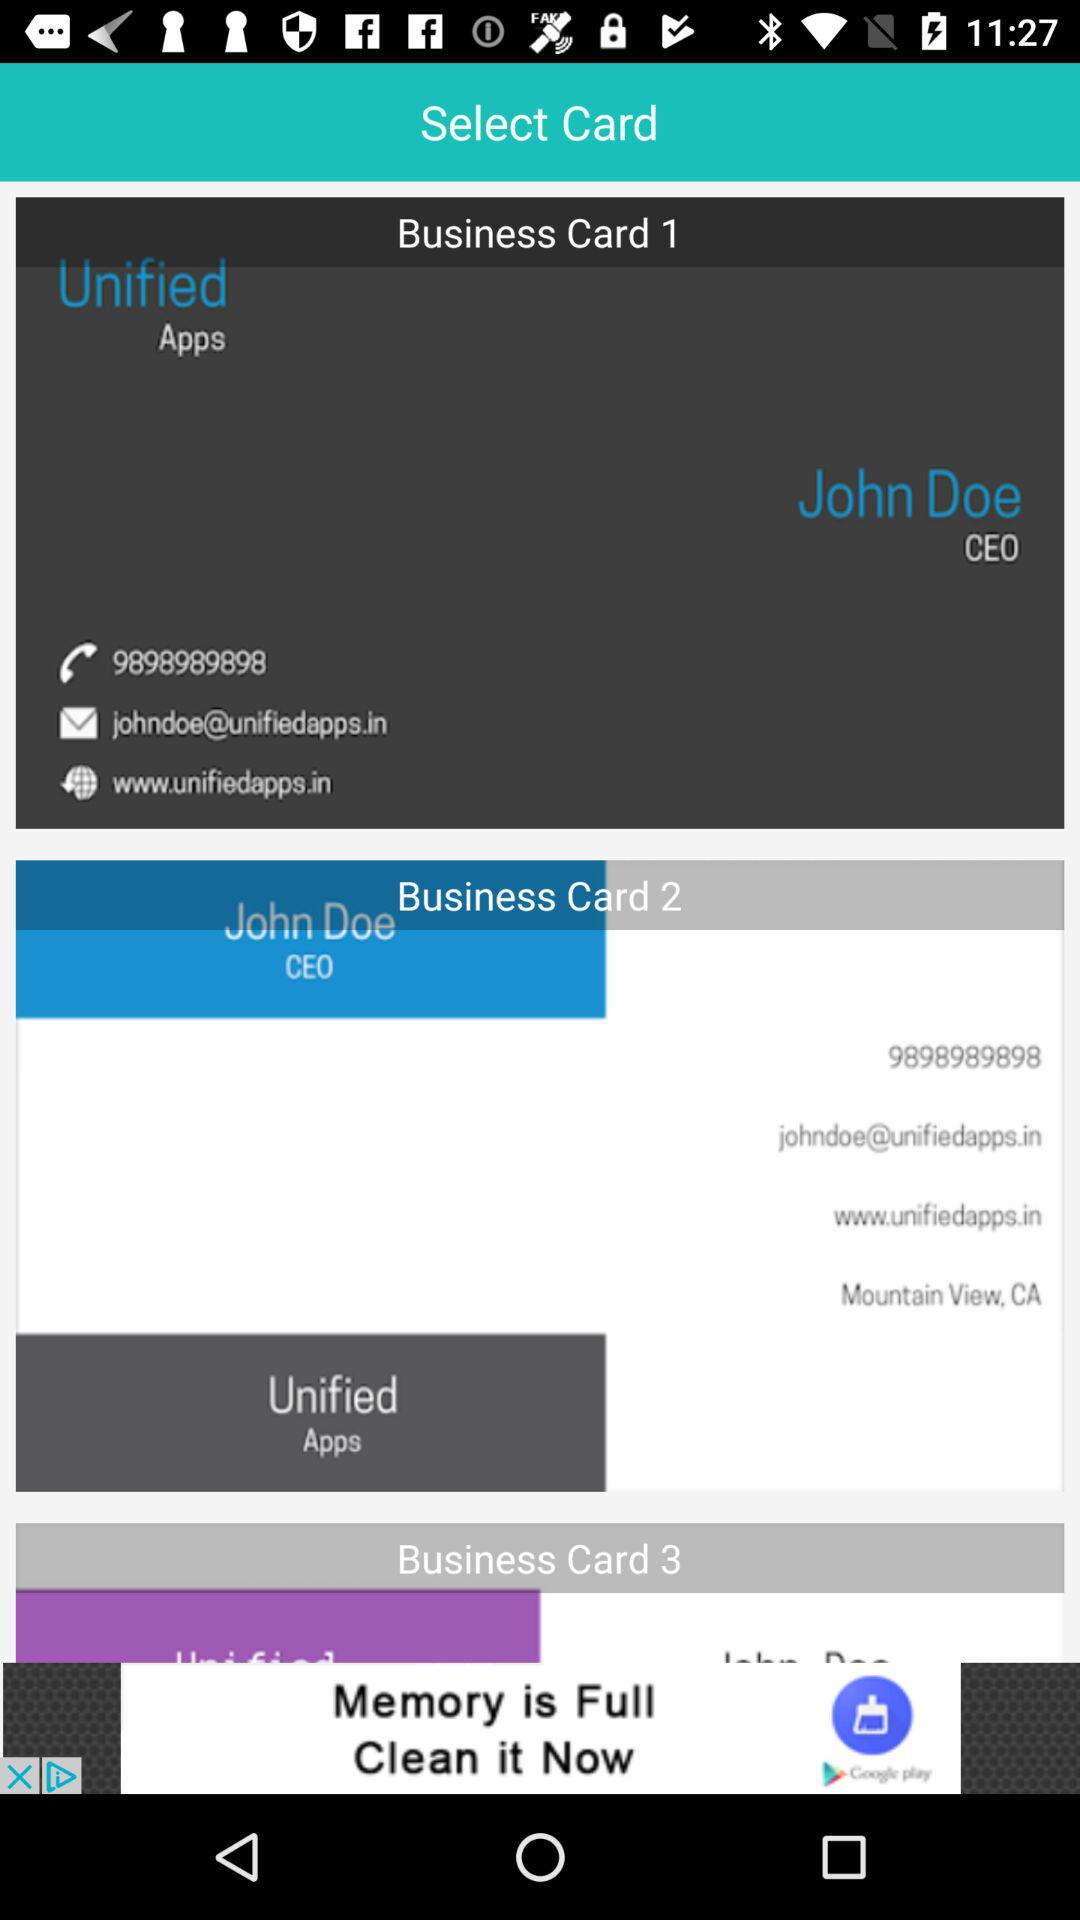What is the application name? The application name is "Unified Apps". 